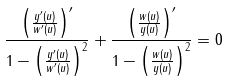Convert formula to latex. <formula><loc_0><loc_0><loc_500><loc_500>\frac { \left ( \frac { y ^ { \prime } ( u ) } { w ^ { \prime } ( u ) } \right ) ^ { \prime } } { 1 - \left ( \frac { y ^ { \prime } ( u ) } { w ^ { \prime } ( u ) } \right ) ^ { 2 } } + \frac { \left ( \frac { w ( u ) } { y ( u ) } \right ) ^ { \prime } } { 1 - \left ( \frac { w ( u ) } { y ( u ) } \right ) ^ { 2 } } = 0</formula> 